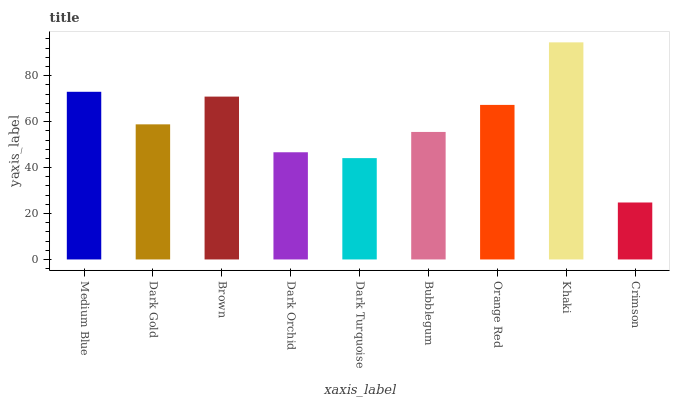Is Crimson the minimum?
Answer yes or no. Yes. Is Khaki the maximum?
Answer yes or no. Yes. Is Dark Gold the minimum?
Answer yes or no. No. Is Dark Gold the maximum?
Answer yes or no. No. Is Medium Blue greater than Dark Gold?
Answer yes or no. Yes. Is Dark Gold less than Medium Blue?
Answer yes or no. Yes. Is Dark Gold greater than Medium Blue?
Answer yes or no. No. Is Medium Blue less than Dark Gold?
Answer yes or no. No. Is Dark Gold the high median?
Answer yes or no. Yes. Is Dark Gold the low median?
Answer yes or no. Yes. Is Brown the high median?
Answer yes or no. No. Is Dark Orchid the low median?
Answer yes or no. No. 